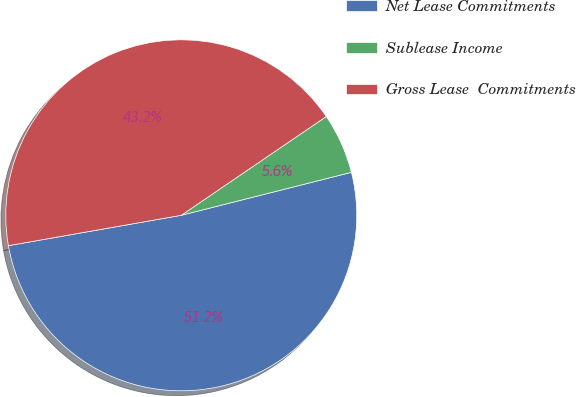Convert chart. <chart><loc_0><loc_0><loc_500><loc_500><pie_chart><fcel>Net Lease Commitments<fcel>Sublease Income<fcel>Gross Lease  Commitments<nl><fcel>51.17%<fcel>5.58%<fcel>43.25%<nl></chart> 